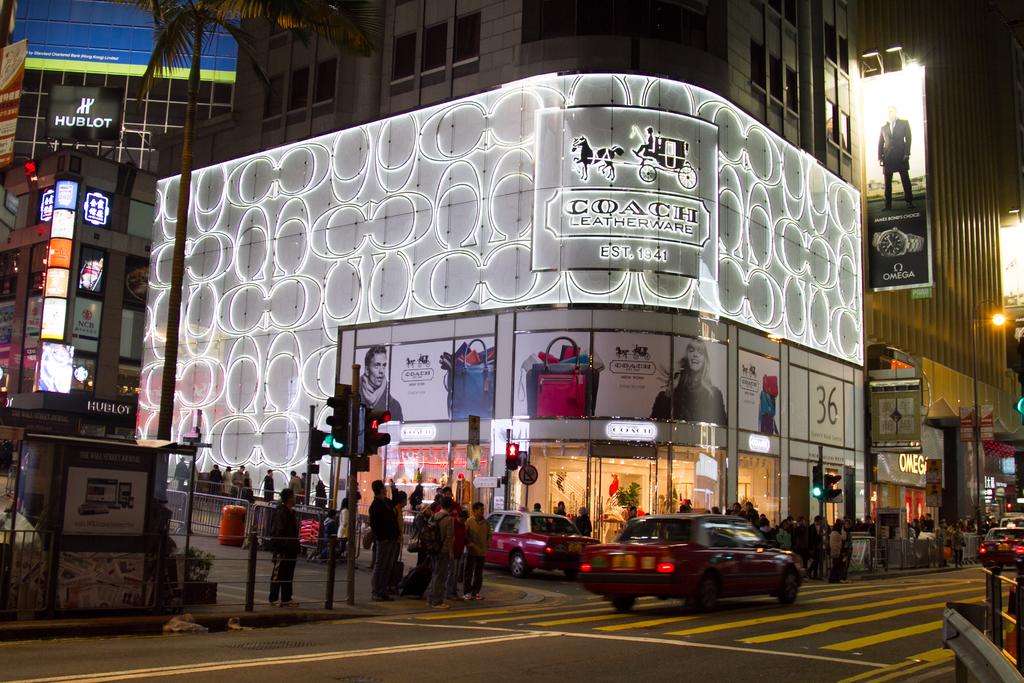What brand owns this store?
Offer a terse response. Coach. What is the name of the store?
Your answer should be compact. Coach. 